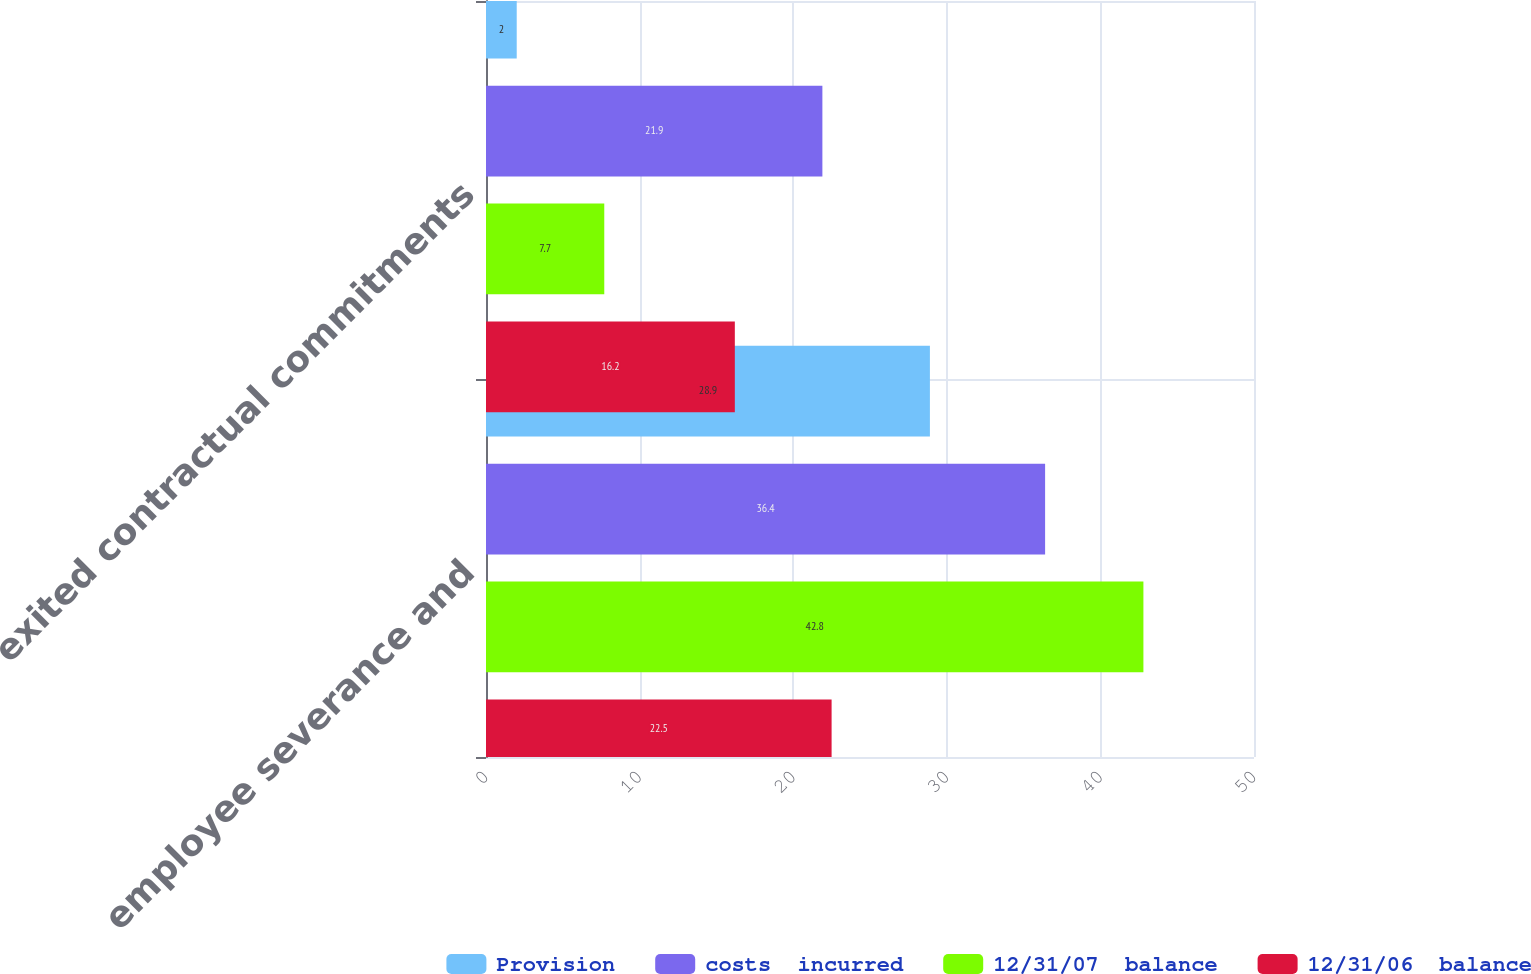<chart> <loc_0><loc_0><loc_500><loc_500><stacked_bar_chart><ecel><fcel>employee severance and<fcel>exited contractual commitments<nl><fcel>Provision<fcel>28.9<fcel>2<nl><fcel>costs  incurred<fcel>36.4<fcel>21.9<nl><fcel>12/31/07  balance<fcel>42.8<fcel>7.7<nl><fcel>12/31/06  balance<fcel>22.5<fcel>16.2<nl></chart> 